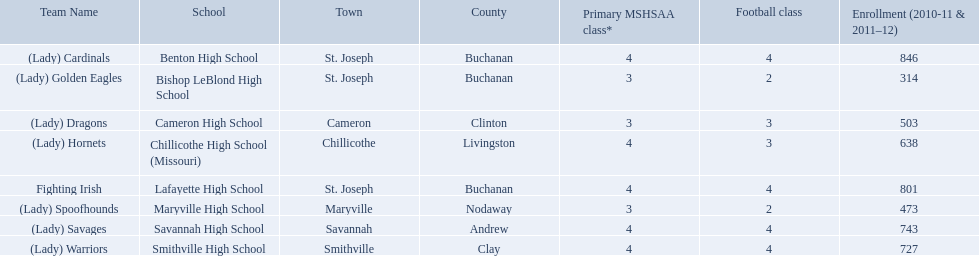What are all of the schools? Benton High School, Bishop LeBlond High School, Cameron High School, Chillicothe High School (Missouri), Lafayette High School, Maryville High School, Savannah High School, Smithville High School. How many football classes do they have? 4, 2, 3, 3, 4, 2, 4, 4. What about their enrollment? 846, 314, 503, 638, 801, 473, 743, 727. Which schools have 3 football classes? Cameron High School, Chillicothe High School (Missouri). And of those schools, which has 638 students? Chillicothe High School (Missouri). 